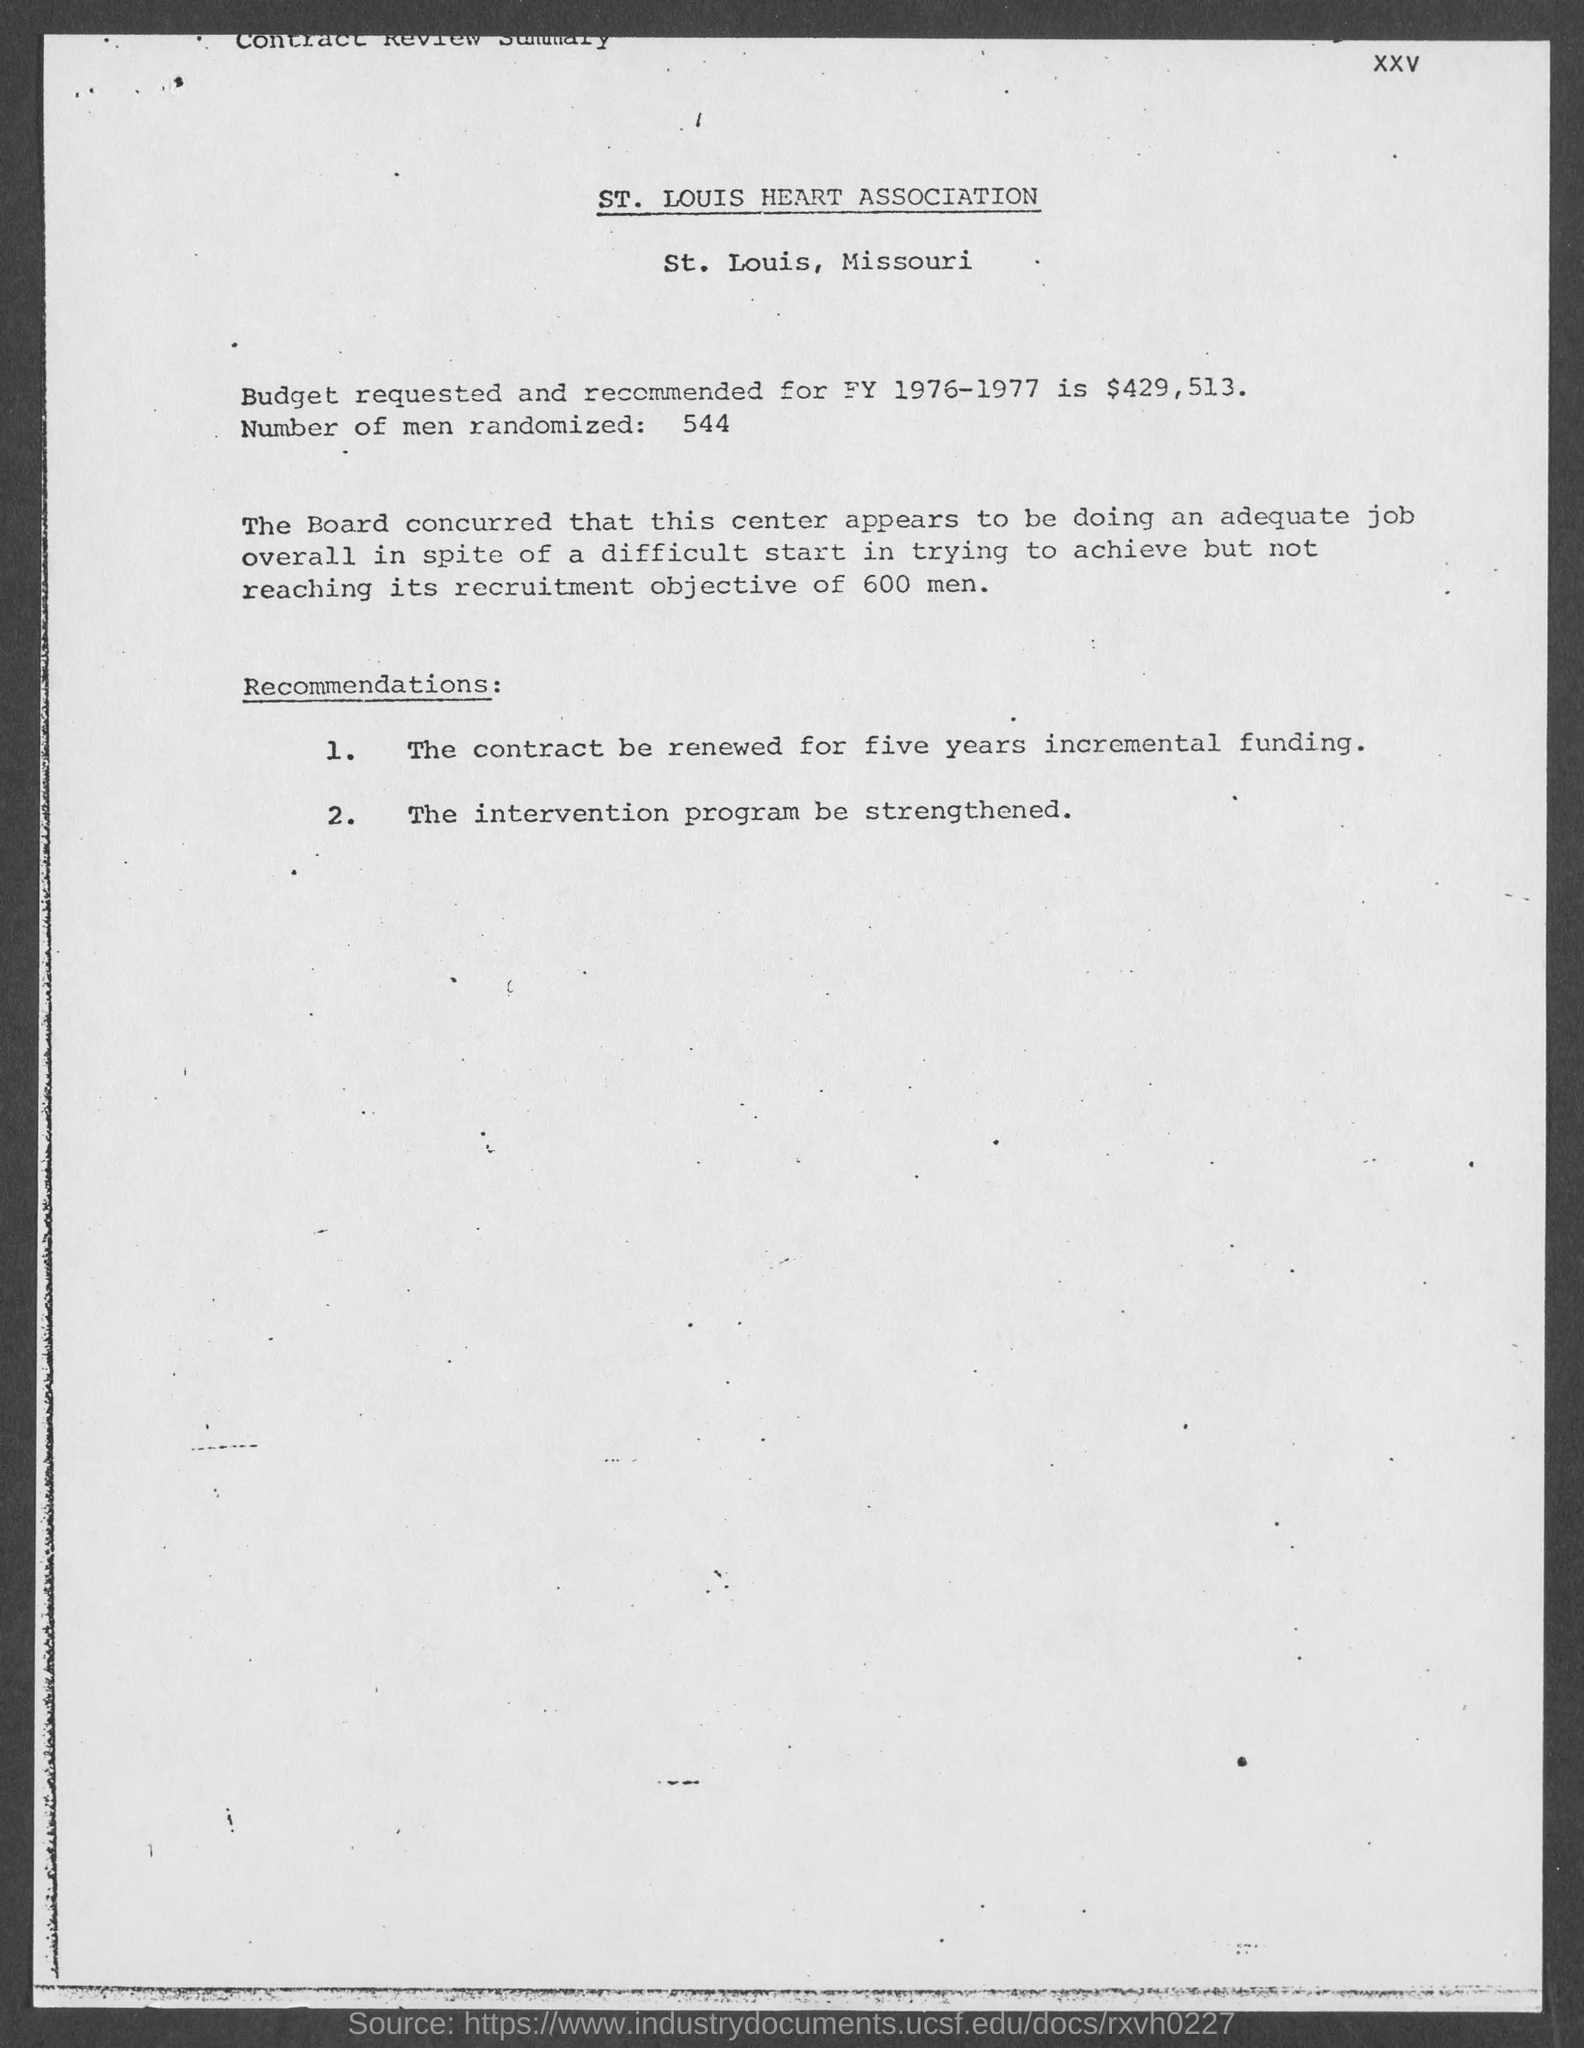Specify some key components in this picture. I am not sure what you are asking. Could you please provide more context or clarify your question? According to the document, 544 men were randomized. 